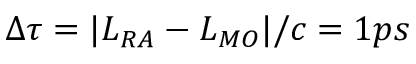Convert formula to latex. <formula><loc_0><loc_0><loc_500><loc_500>\Delta \tau = | L _ { R A } - L _ { M O } | / c = 1 p s</formula> 